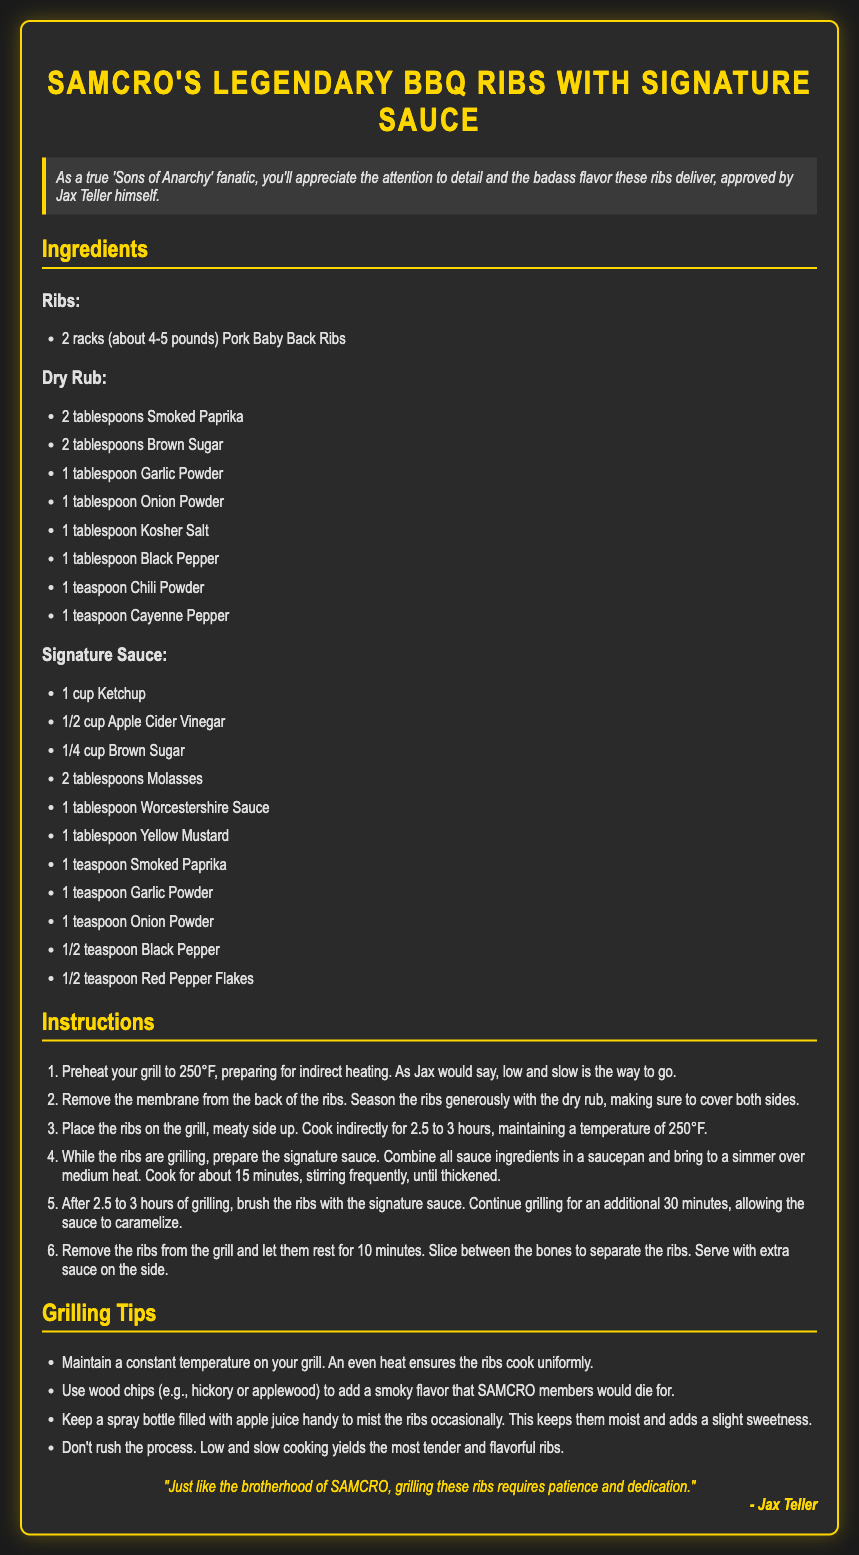What type of ribs are used in this recipe? The recipe specifies "Pork Baby Back Ribs" as the type of ribs used.
Answer: Pork Baby Back Ribs How many tablespoons of smoked paprika are needed for the dry rub? The recipe lists "2 tablespoons" of smoked paprika as required for the dry rub.
Answer: 2 tablespoons What is the cooking temperature for grilling the ribs? The recipe instructs to preheat the grill to "250°F" for cooking the ribs.
Answer: 250°F How long should the ribs grill for? The instructions state that the ribs should be grilled for "2.5 to 3 hours".
Answer: 2.5 to 3 hours What is the first step in the instructions for preparing the ribs? The first step mentioned is to "Preheat your grill to 250°F," indicating the initial preparation.
Answer: Preheat your grill to 250°F Which ingredient is used to add a smoky flavor to the ribs? The grilling tips suggest using "wood chips (e.g., hickory or applewood)" to add a smoky flavor.
Answer: Wood chips How long should the sauce simmer in preparation? The instructions state to cook the sauce for "about 15 minutes."
Answer: About 15 minutes What does Jax Teller suggest about cooking ribs? Jax Teller emphasizes that "low and slow is the way to go" for rib cooking methods.
Answer: Low and slow What should you keep handy to mist the ribs? The grilling tips recommend keeping a "spray bottle filled with apple juice" to mist the ribs.
Answer: Spray bottle filled with apple juice 